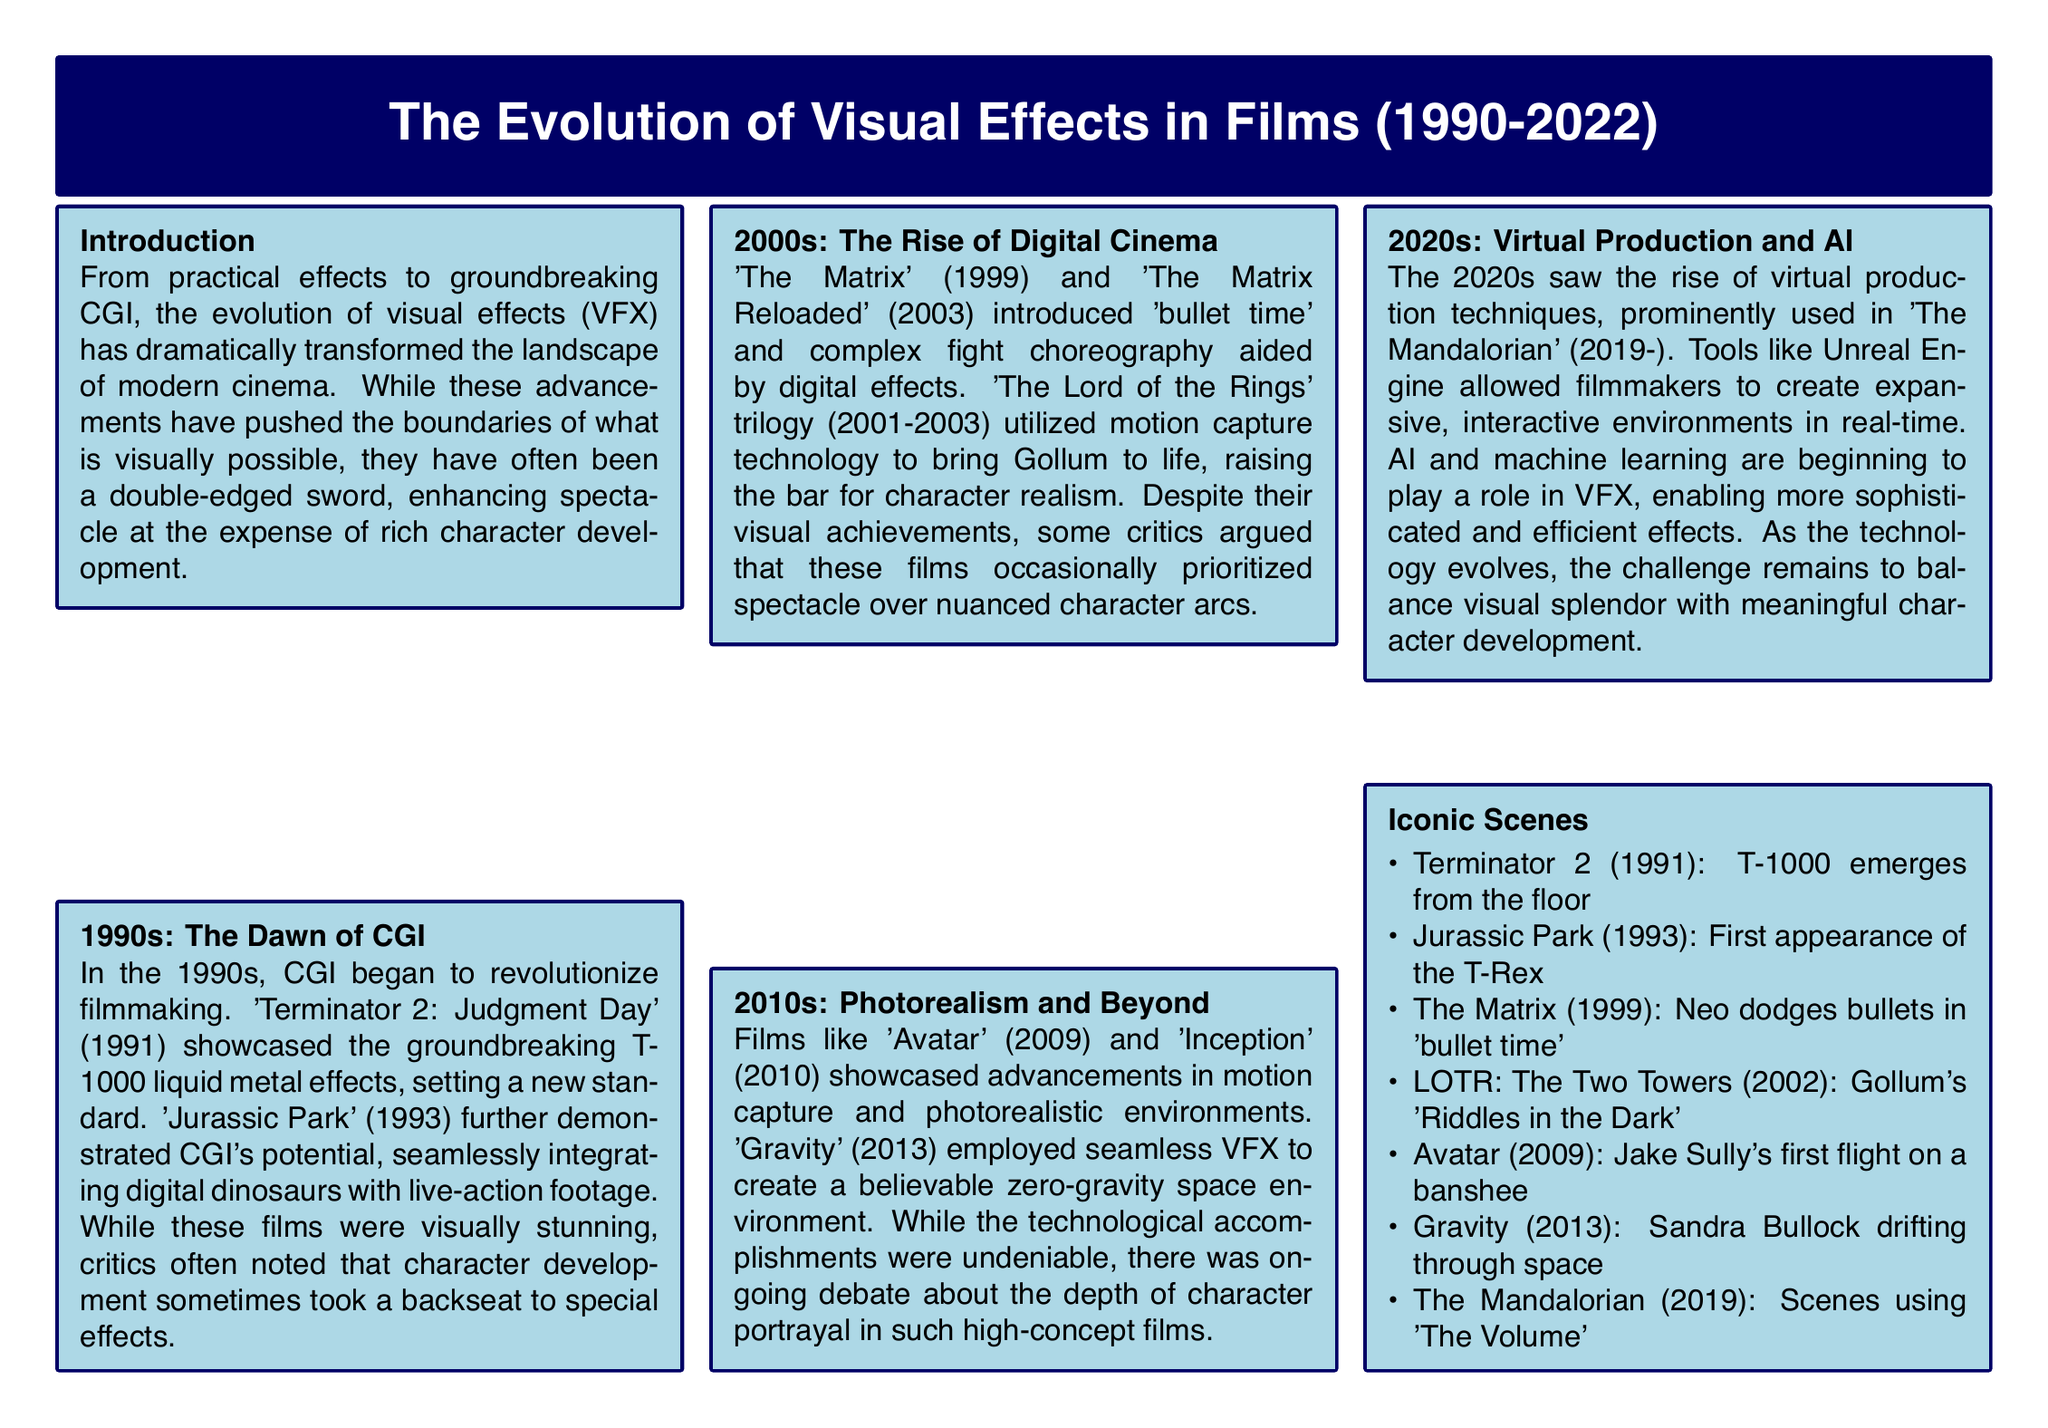What film showcased the T-1000 effects? 'Terminator 2: Judgment Day' (1991) is mentioned as the film that showcased the T-1000 liquid metal effects.
Answer: 'Terminator 2: Judgment Day' Which technology was used to bring Gollum to life? The document states that 'The Lord of the Rings' trilogy utilized motion capture technology for Gollum.
Answer: Motion capture technology In what year did 'Avatar' premiere? The document lists 'Avatar' (2009) as a film showcasing advancements in motion capture and photorealistic environments.
Answer: 2009 What is the iconic scene from 'Gravity'? The document mentions Sandra Bullock drifting through space as the iconic scene from 'Gravity' (2013).
Answer: Sandra Bullock drifting through space What advancement is highlighted in the 2020s section? The section details the rise of virtual production techniques, particularly in relation to 'The Mandalorian.'
Answer: Virtual production techniques How did critics view the relationship between visual effects and character development? The document notes that critics often felt character development took a backseat to effects in several films.
Answer: Took a backseat What film introduced 'bullet time'? 'The Matrix' (1999) is noted for introducing 'bullet time' in its action sequences.
Answer: 'The Matrix' What tool is mentioned as allowing the creation of interactive environments? Unreal Engine is referenced as a tool for creating expansive interactive environments in the 2020s.
Answer: Unreal Engine 